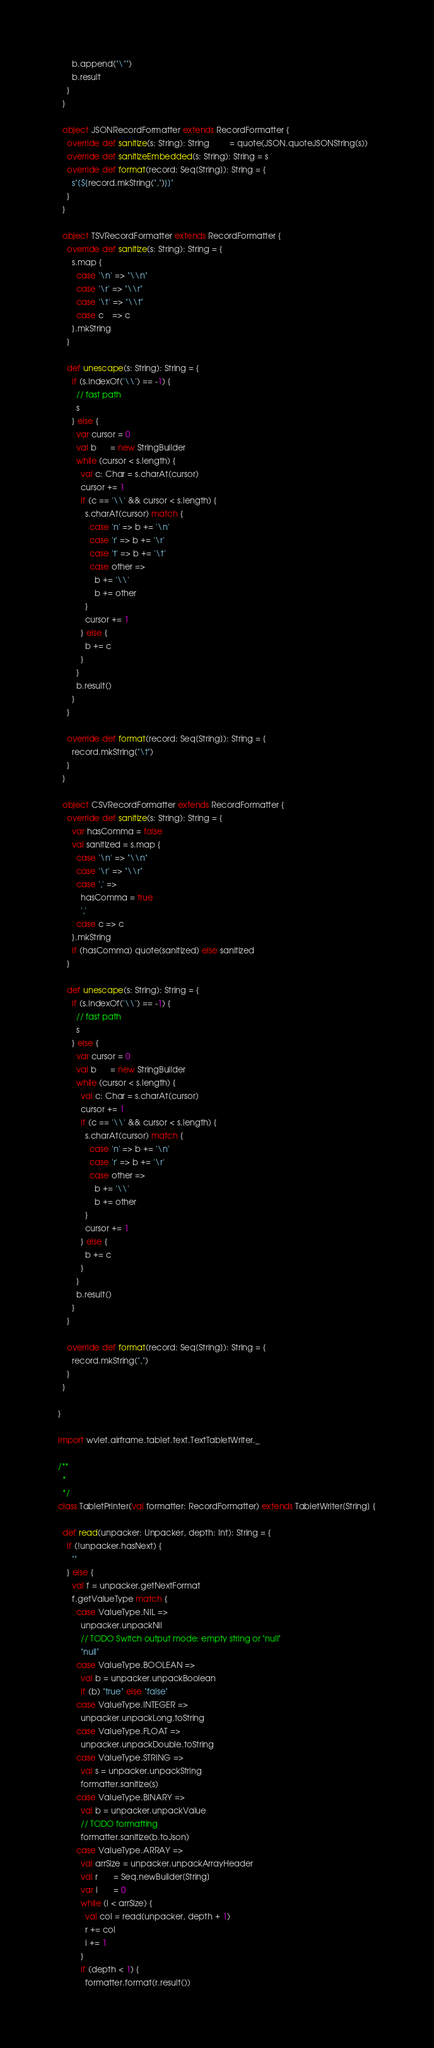<code> <loc_0><loc_0><loc_500><loc_500><_Scala_>      b.append("\"")
      b.result
    }
  }

  object JSONRecordFormatter extends RecordFormatter {
    override def sanitize(s: String): String         = quote(JSON.quoteJSONString(s))
    override def sanitizeEmbedded(s: String): String = s
    override def format(record: Seq[String]): String = {
      s"[${record.mkString(",")}]"
    }
  }

  object TSVRecordFormatter extends RecordFormatter {
    override def sanitize(s: String): String = {
      s.map {
        case '\n' => "\\n"
        case '\r' => "\\r"
        case '\t' => "\\t"
        case c    => c
      }.mkString
    }

    def unescape(s: String): String = {
      if (s.indexOf('\\') == -1) {
        // fast path
        s
      } else {
        var cursor = 0
        val b      = new StringBuilder
        while (cursor < s.length) {
          val c: Char = s.charAt(cursor)
          cursor += 1
          if (c == '\\' && cursor < s.length) {
            s.charAt(cursor) match {
              case 'n' => b += '\n'
              case 'r' => b += '\r'
              case 't' => b += '\t'
              case other =>
                b += '\\'
                b += other
            }
            cursor += 1
          } else {
            b += c
          }
        }
        b.result()
      }
    }

    override def format(record: Seq[String]): String = {
      record.mkString("\t")
    }
  }

  object CSVRecordFormatter extends RecordFormatter {
    override def sanitize(s: String): String = {
      var hasComma = false
      val sanitized = s.map {
        case '\n' => "\\n"
        case '\r' => "\\r"
        case ',' =>
          hasComma = true
          ','
        case c => c
      }.mkString
      if (hasComma) quote(sanitized) else sanitized
    }

    def unescape(s: String): String = {
      if (s.indexOf('\\') == -1) {
        // fast path
        s
      } else {
        var cursor = 0
        val b      = new StringBuilder
        while (cursor < s.length) {
          val c: Char = s.charAt(cursor)
          cursor += 1
          if (c == '\\' && cursor < s.length) {
            s.charAt(cursor) match {
              case 'n' => b += '\n'
              case 'r' => b += '\r'
              case other =>
                b += '\\'
                b += other
            }
            cursor += 1
          } else {
            b += c
          }
        }
        b.result()
      }
    }

    override def format(record: Seq[String]): String = {
      record.mkString(",")
    }
  }

}

import wvlet.airframe.tablet.text.TextTabletWriter._

/**
  *
  */
class TabletPrinter(val formatter: RecordFormatter) extends TabletWriter[String] {

  def read(unpacker: Unpacker, depth: Int): String = {
    if (!unpacker.hasNext) {
      ""
    } else {
      val f = unpacker.getNextFormat
      f.getValueType match {
        case ValueType.NIL =>
          unpacker.unpackNil
          // TODO Switch output mode: empty string or "null"
          "null"
        case ValueType.BOOLEAN =>
          val b = unpacker.unpackBoolean
          if (b) "true" else "false"
        case ValueType.INTEGER =>
          unpacker.unpackLong.toString
        case ValueType.FLOAT =>
          unpacker.unpackDouble.toString
        case ValueType.STRING =>
          val s = unpacker.unpackString
          formatter.sanitize(s)
        case ValueType.BINARY =>
          val b = unpacker.unpackValue
          // TODO formatting
          formatter.sanitize(b.toJson)
        case ValueType.ARRAY =>
          val arrSize = unpacker.unpackArrayHeader
          val r       = Seq.newBuilder[String]
          var i       = 0
          while (i < arrSize) {
            val col = read(unpacker, depth + 1)
            r += col
            i += 1
          }
          if (depth < 1) {
            formatter.format(r.result())</code> 